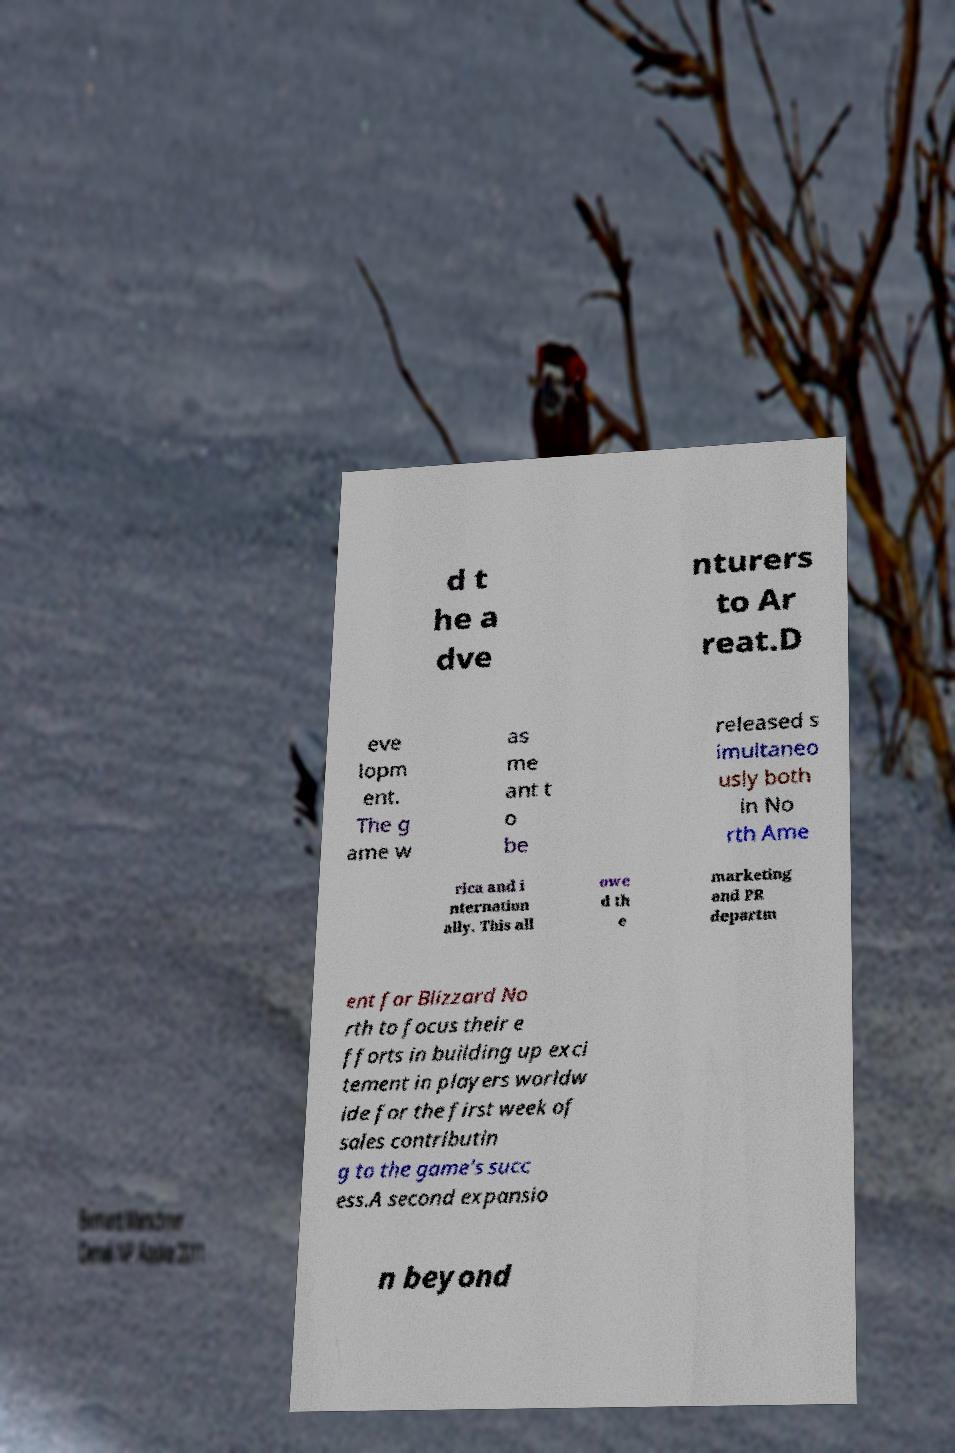Please identify and transcribe the text found in this image. d t he a dve nturers to Ar reat.D eve lopm ent. The g ame w as me ant t o be released s imultaneo usly both in No rth Ame rica and i nternation ally. This all owe d th e marketing and PR departm ent for Blizzard No rth to focus their e fforts in building up exci tement in players worldw ide for the first week of sales contributin g to the game's succ ess.A second expansio n beyond 